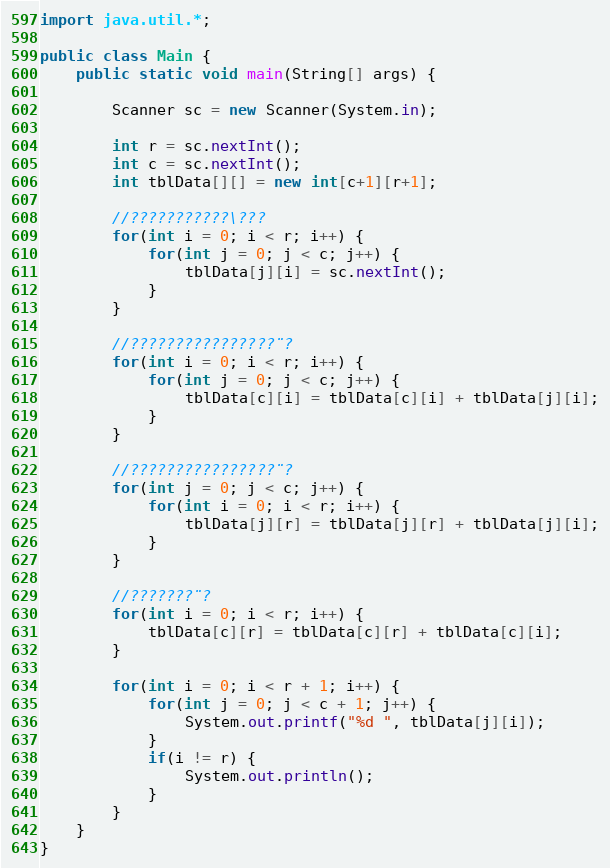Convert code to text. <code><loc_0><loc_0><loc_500><loc_500><_Java_>import java.util.*;

public class Main {
	public static void main(String[] args) {
		
		Scanner sc = new Scanner(System.in);

		int r = sc.nextInt();
		int c = sc.nextInt();
		int tblData[][] = new int[c+1][r+1];
		
		//???????????\???
		for(int i = 0; i < r; i++) {
			for(int j = 0; j < c; j++) {
				tblData[j][i] = sc.nextInt();
			}
		}
		
		//????????????????¨?
		for(int i = 0; i < r; i++) {
			for(int j = 0; j < c; j++) {
				tblData[c][i] = tblData[c][i] + tblData[j][i];
			}
		}
		
		//????????????????¨?
		for(int j = 0; j < c; j++) {
			for(int i = 0; i < r; i++) {
				tblData[j][r] = tblData[j][r] + tblData[j][i];
			}
		}
		
		//???????¨?
		for(int i = 0; i < r; i++) {
			tblData[c][r] = tblData[c][r] + tblData[c][i];
		}
		
		for(int i = 0; i < r + 1; i++) {
			for(int j = 0; j < c + 1; j++) {
				System.out.printf("%d ", tblData[j][i]);
			}
			if(i != r) {
				System.out.println();
			}
		}
	}
}</code> 